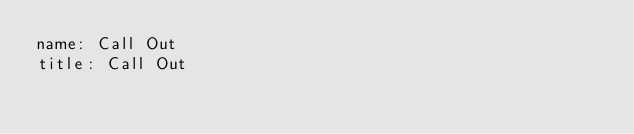Convert code to text. <code><loc_0><loc_0><loc_500><loc_500><_YAML_>name: Call Out
title: Call Out
</code> 